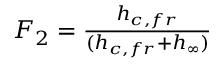Convert formula to latex. <formula><loc_0><loc_0><loc_500><loc_500>\begin{array} { r } { F _ { 2 } = \frac { h _ { c , f r } } { ( h _ { c , f r } + h _ { \infty } ) } } \end{array}</formula> 